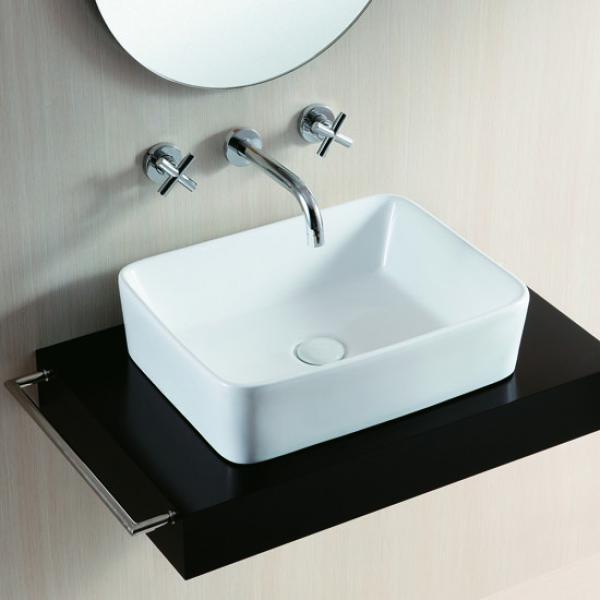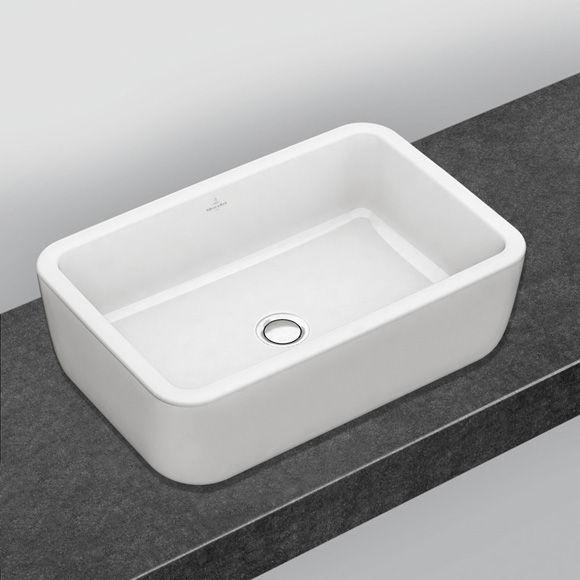The first image is the image on the left, the second image is the image on the right. Analyze the images presented: Is the assertion "There are two rectangular sinks with faucets attached to counter tops." valid? Answer yes or no. No. The first image is the image on the left, the second image is the image on the right. Considering the images on both sides, is "Each of the sinks are attached to a black wall." valid? Answer yes or no. No. 